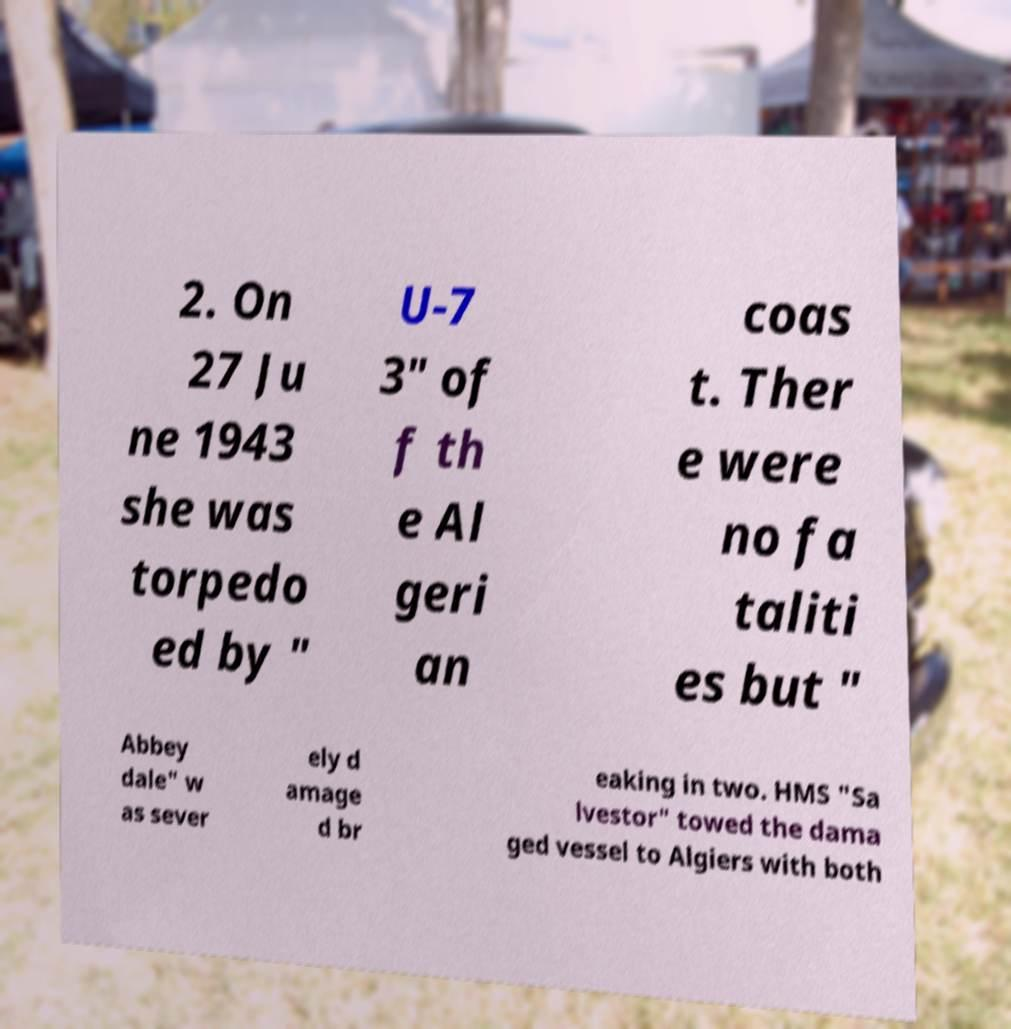Can you accurately transcribe the text from the provided image for me? 2. On 27 Ju ne 1943 she was torpedo ed by " U-7 3" of f th e Al geri an coas t. Ther e were no fa taliti es but " Abbey dale" w as sever ely d amage d br eaking in two. HMS "Sa lvestor" towed the dama ged vessel to Algiers with both 